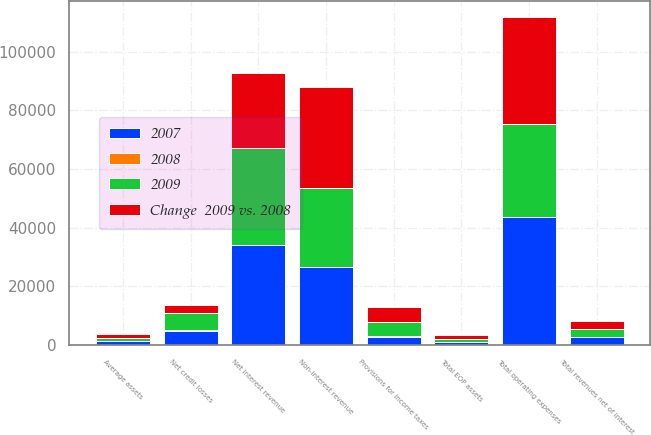Convert chart. <chart><loc_0><loc_0><loc_500><loc_500><stacked_bar_chart><ecel><fcel>Net interest revenue<fcel>Non-interest revenue<fcel>Total revenues net of interest<fcel>Net credit losses<fcel>Total operating expenses<fcel>Provisions for income taxes<fcel>Total EOP assets<fcel>Average assets<nl><fcel>2009<fcel>33263<fcel>26943<fcel>2700<fcel>6079<fcel>31725<fcel>4875<fcel>1079<fcel>1035<nl><fcel>2007<fcel>33970<fcel>26585<fcel>2700<fcel>4941<fcel>43533<fcel>2882<fcel>1002<fcel>1256<nl><fcel>Change  2009 vs. 2008<fcel>25600<fcel>34497<fcel>2700<fcel>2700<fcel>36437<fcel>5238<fcel>1222<fcel>1353<nl><fcel>2008<fcel>2<fcel>1<fcel>1<fcel>23<fcel>27<fcel>69<fcel>8<fcel>18<nl></chart> 